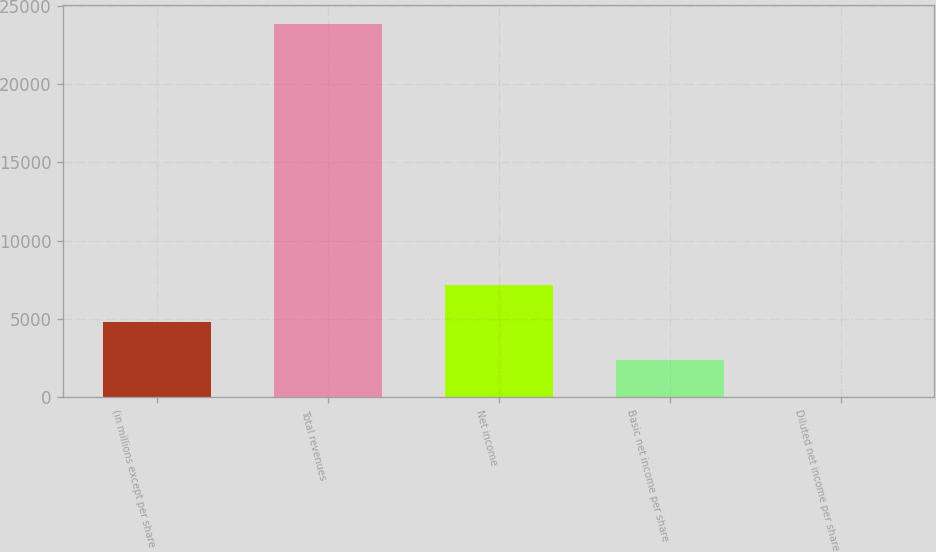<chart> <loc_0><loc_0><loc_500><loc_500><bar_chart><fcel>(in millions except per share<fcel>Total revenues<fcel>Net income<fcel>Basic net income per share<fcel>Diluted net income per share<nl><fcel>4774.19<fcel>23867<fcel>7160.79<fcel>2387.59<fcel>0.99<nl></chart> 